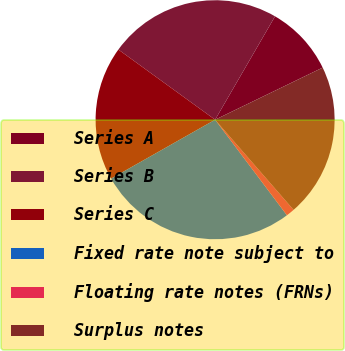<chart> <loc_0><loc_0><loc_500><loc_500><pie_chart><fcel>Series A<fcel>Series B<fcel>Series C<fcel>Fixed rate note subject to<fcel>Floating rate notes (FRNs)<fcel>Surplus notes<nl><fcel>9.46%<fcel>23.37%<fcel>18.19%<fcel>27.06%<fcel>1.14%<fcel>20.78%<nl></chart> 